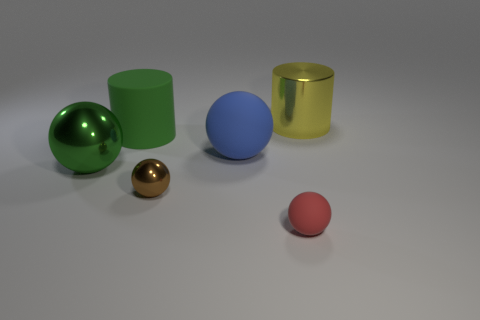The thing that is the same color as the large metal sphere is what size?
Keep it short and to the point. Large. What shape is the green rubber thing that is the same size as the metallic cylinder?
Keep it short and to the point. Cylinder. How many objects are objects right of the red sphere or shiny objects that are on the left side of the blue sphere?
Your answer should be very brief. 3. Are there fewer big green metallic things than large red matte objects?
Your answer should be very brief. No. There is a blue thing that is the same size as the green rubber cylinder; what is it made of?
Provide a succinct answer. Rubber. Is the size of the metallic object left of the brown sphere the same as the cylinder in front of the yellow shiny object?
Offer a terse response. Yes. Are there any spheres that have the same material as the small brown thing?
Your response must be concise. Yes. What number of objects are either objects that are left of the matte cylinder or green things?
Your answer should be compact. 2. Do the small object on the left side of the red ball and the tiny red ball have the same material?
Keep it short and to the point. No. Is the shape of the red thing the same as the large blue object?
Provide a succinct answer. Yes. 